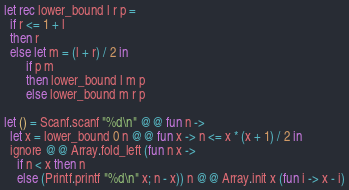Convert code to text. <code><loc_0><loc_0><loc_500><loc_500><_OCaml_>let rec lower_bound l r p =
  if r <= 1 + l
  then r
  else let m = (l + r) / 2 in
       if p m
       then lower_bound l m p
       else lower_bound m r p

let () = Scanf.scanf "%d\n" @@ fun n ->
  let x = lower_bound 0 n @@ fun x -> n <= x * (x + 1) / 2 in
  ignore @@ Array.fold_left (fun n x ->
    if n < x then n
    else (Printf.printf "%d\n" x; n - x)) n @@ Array.init x (fun i -> x - i)
</code> 